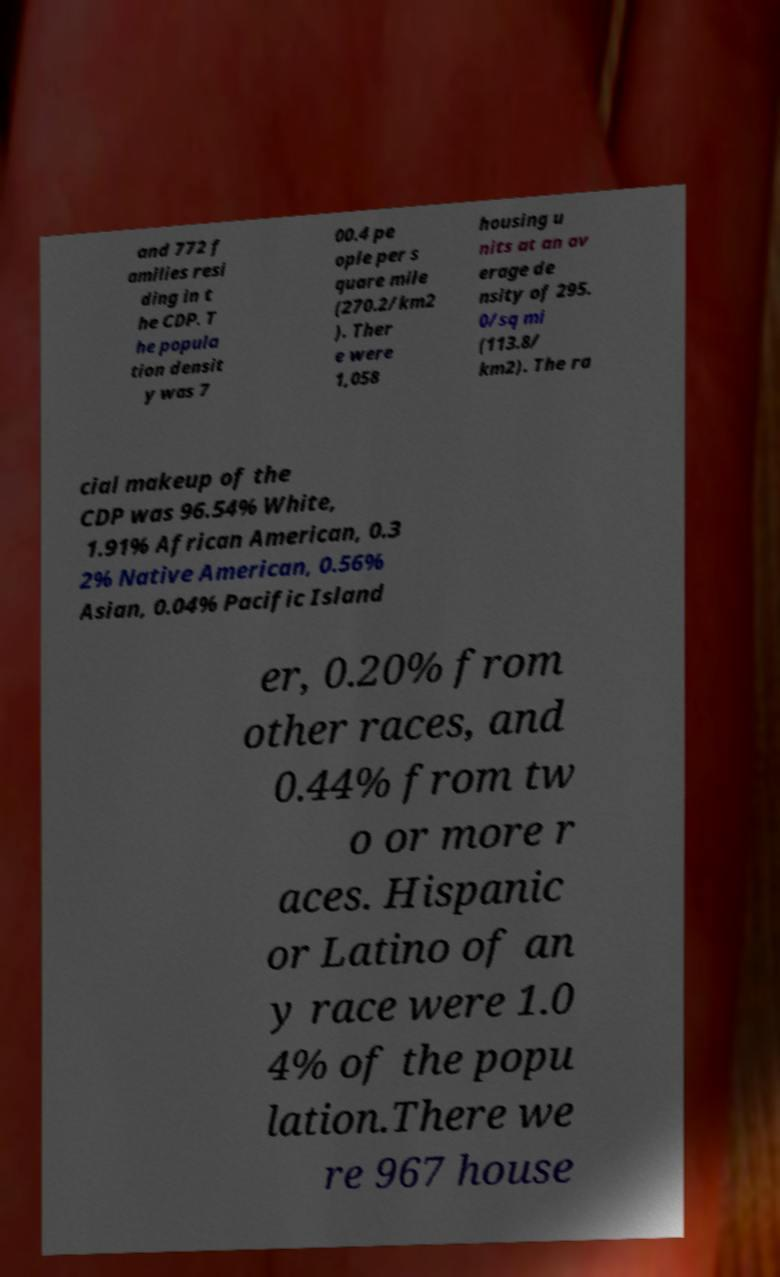Can you read and provide the text displayed in the image?This photo seems to have some interesting text. Can you extract and type it out for me? and 772 f amilies resi ding in t he CDP. T he popula tion densit y was 7 00.4 pe ople per s quare mile (270.2/km2 ). Ther e were 1,058 housing u nits at an av erage de nsity of 295. 0/sq mi (113.8/ km2). The ra cial makeup of the CDP was 96.54% White, 1.91% African American, 0.3 2% Native American, 0.56% Asian, 0.04% Pacific Island er, 0.20% from other races, and 0.44% from tw o or more r aces. Hispanic or Latino of an y race were 1.0 4% of the popu lation.There we re 967 house 